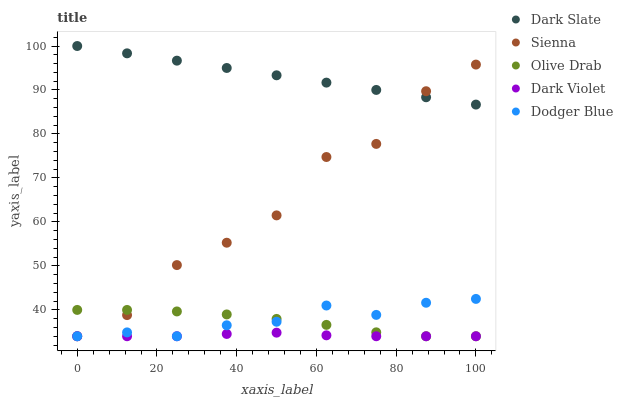Does Dark Violet have the minimum area under the curve?
Answer yes or no. Yes. Does Dark Slate have the maximum area under the curve?
Answer yes or no. Yes. Does Dodger Blue have the minimum area under the curve?
Answer yes or no. No. Does Dodger Blue have the maximum area under the curve?
Answer yes or no. No. Is Dark Slate the smoothest?
Answer yes or no. Yes. Is Sienna the roughest?
Answer yes or no. Yes. Is Dodger Blue the smoothest?
Answer yes or no. No. Is Dodger Blue the roughest?
Answer yes or no. No. Does Sienna have the lowest value?
Answer yes or no. Yes. Does Dark Slate have the lowest value?
Answer yes or no. No. Does Dark Slate have the highest value?
Answer yes or no. Yes. Does Dodger Blue have the highest value?
Answer yes or no. No. Is Olive Drab less than Dark Slate?
Answer yes or no. Yes. Is Dark Slate greater than Olive Drab?
Answer yes or no. Yes. Does Sienna intersect Dark Slate?
Answer yes or no. Yes. Is Sienna less than Dark Slate?
Answer yes or no. No. Is Sienna greater than Dark Slate?
Answer yes or no. No. Does Olive Drab intersect Dark Slate?
Answer yes or no. No. 